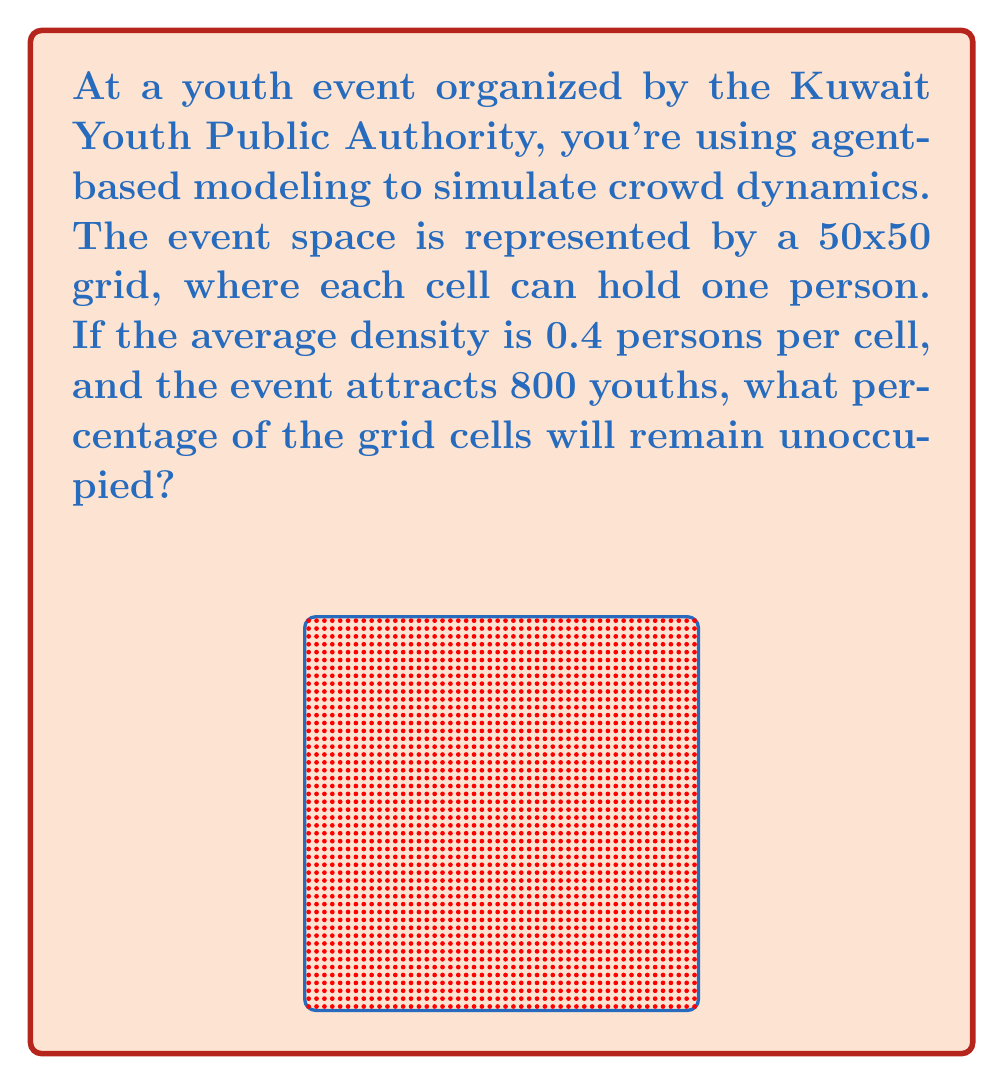Can you solve this math problem? Let's approach this step-by-step:

1) First, calculate the total number of cells in the grid:
   $$ \text{Total cells} = 50 \times 50 = 2500 \text{ cells} $$

2) Given the average density of 0.4 persons per cell, we can calculate the number of occupied cells:
   $$ \text{Occupied cells} = 800 \text{ youths} \div 0.4 \text{ persons/cell} = 2000 \text{ cells} $$

3) To find the number of unoccupied cells, subtract the occupied cells from the total:
   $$ \text{Unoccupied cells} = 2500 - 2000 = 500 \text{ cells} $$

4) To calculate the percentage of unoccupied cells, divide the number of unoccupied cells by the total number of cells and multiply by 100:
   $$ \text{Percentage unoccupied} = \frac{500}{2500} \times 100 = 20\% $$

Therefore, 20% of the grid cells will remain unoccupied.
Answer: 20% 